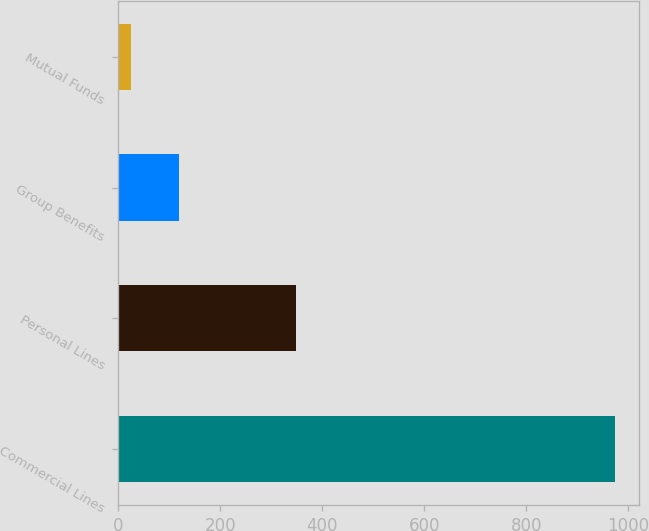Convert chart to OTSL. <chart><loc_0><loc_0><loc_500><loc_500><bar_chart><fcel>Commercial Lines<fcel>Personal Lines<fcel>Group Benefits<fcel>Mutual Funds<nl><fcel>973<fcel>348<fcel>118.9<fcel>24<nl></chart> 